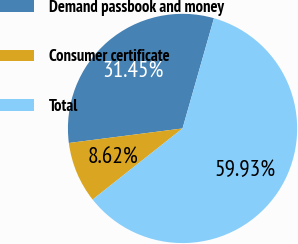Convert chart to OTSL. <chart><loc_0><loc_0><loc_500><loc_500><pie_chart><fcel>Demand passbook and money<fcel>Consumer certificate<fcel>Total<nl><fcel>31.45%<fcel>8.62%<fcel>59.93%<nl></chart> 